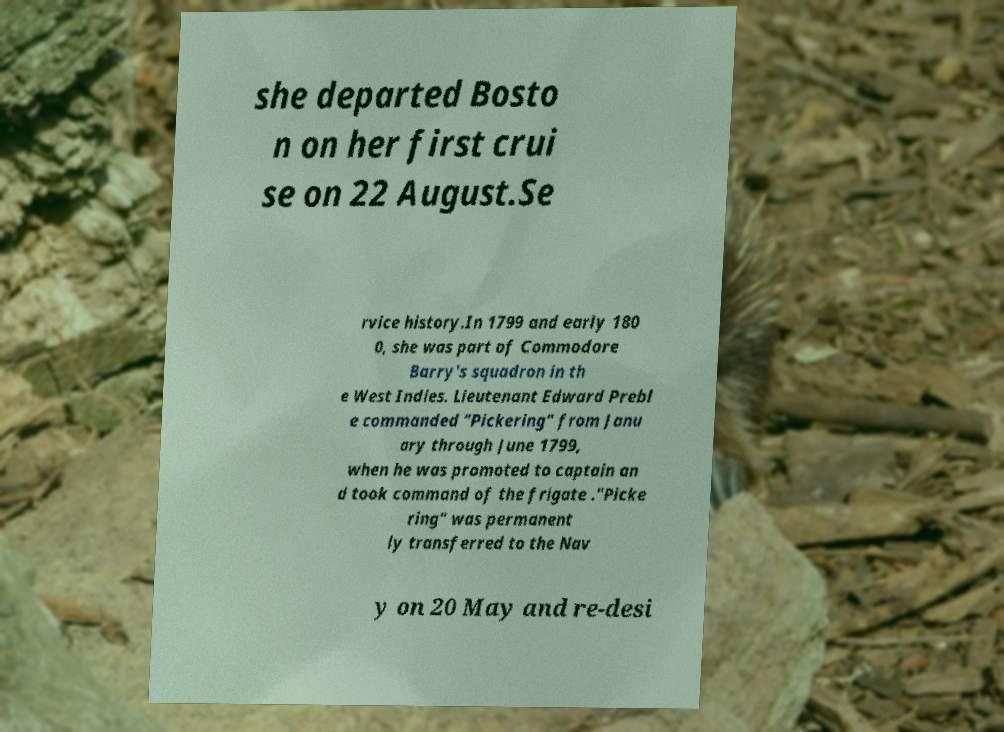I need the written content from this picture converted into text. Can you do that? she departed Bosto n on her first crui se on 22 August.Se rvice history.In 1799 and early 180 0, she was part of Commodore Barry's squadron in th e West Indies. Lieutenant Edward Prebl e commanded "Pickering" from Janu ary through June 1799, when he was promoted to captain an d took command of the frigate ."Picke ring" was permanent ly transferred to the Nav y on 20 May and re-desi 